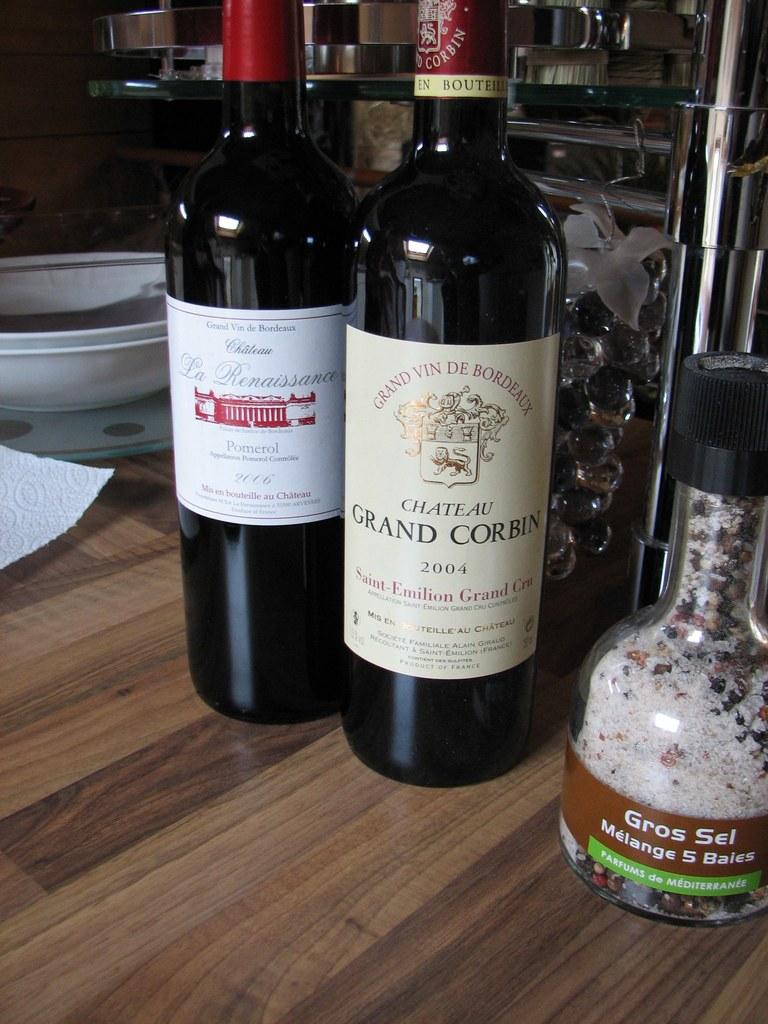What are the brands of wine available?
Give a very brief answer. Grand corbin. What is the name of the seasoning?
Offer a terse response. Gros sel. 